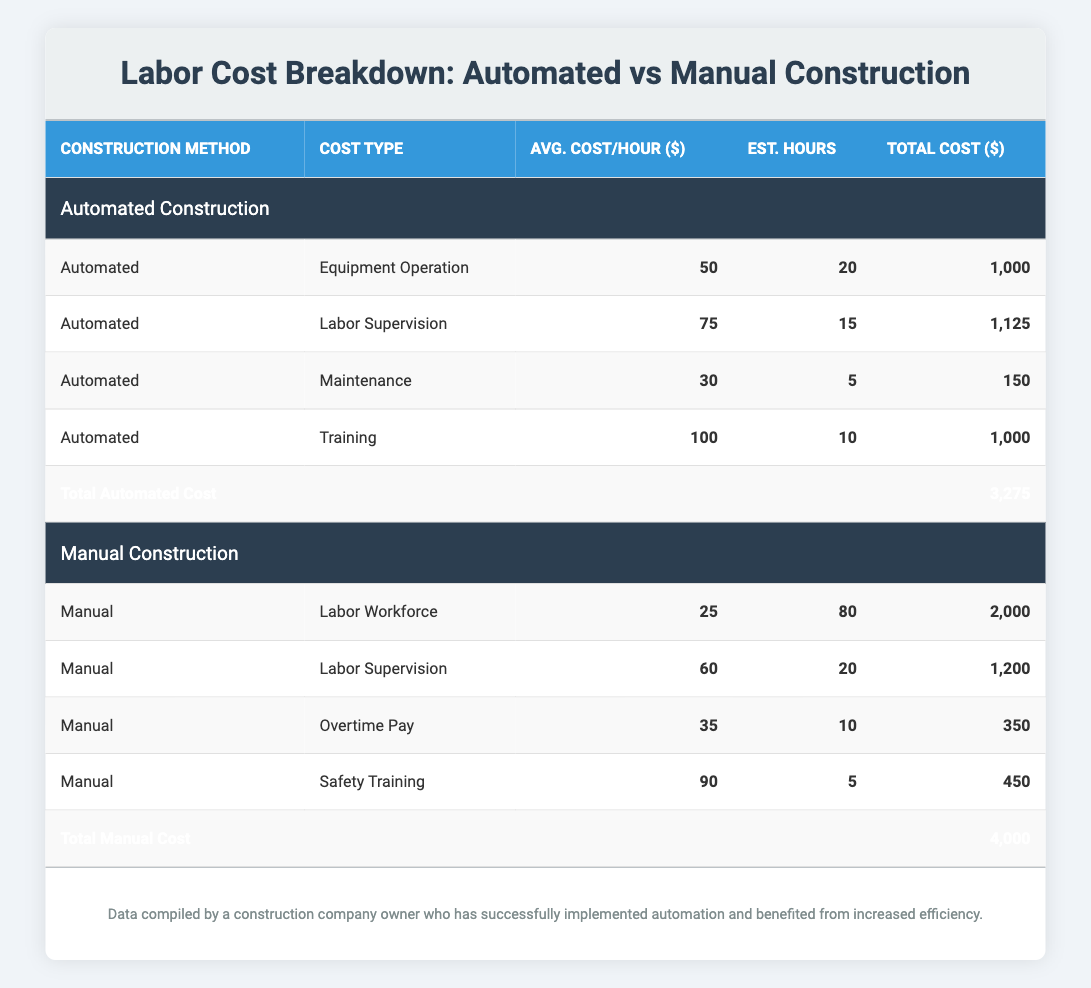What is the total labor cost for automated construction? To find the total for automated construction, we add all the total costs for this method: 1000 + 1125 + 150 + 1000 = 3275.
Answer: 3275 What is the average cost per hour for the labor supervision in manual construction? The average cost per hour for labor supervision in manual construction is explicitly listed in the table as 60.
Answer: 60 Is the total cost of automated construction lower than that of manual construction? The total cost for automated construction is 3275, and for manual construction, it is 4000. Since 3275 is less than 4000, the statement is true.
Answer: Yes What is the difference in total costs between automated and manual construction methods? To find the difference, subtract the total automated cost from the total manual cost: 4000 - 3275 = 725.
Answer: 725 What is the highest average cost per hour across all listed cost types in automated construction? By looking at the average costs per hour in automated construction: 50 (Equipment Operation), 75 (Labor Supervision), 30 (Maintenance), and 100 (Training), the highest is 100 (Training).
Answer: 100 What percentage of the total cost for manual construction is attributed to the labor workforce? The labor workforce cost in manual construction is 2000, and the total manual cost is 4000. To find the percentage: (2000 / 4000) * 100 = 50%.
Answer: 50% Which construction method has a higher total cost for supervision? The total cost for labor supervision in automated construction is 1125 and for manual construction is 1200. Manual construction has higher supervision costs.
Answer: Manual What is the total of the estimated hours for maintenance and safety training together? The estimated hours for maintenance in automated construction is 5 and for safety training in manual construction is also 5. Adding these gives: 5 + 5 = 10.
Answer: 10 What is the overall average cost per hour when both construction methods are considered? For automated construction, the average of costs per hour are 50, 75, 30, and 100, which sums to 255. For manual, the values are 25, 60, 35, and 90, which sums to 210. Combined total hours are 20 + 15 + 5 + 10 (automated) = 50 and 80 + 20 + 10 + 5 (manual) = 115 hours. The overall average is (255 + 210) / (50 + 115) = 465 / 165 = 2.82. Therefore: (Total hours = 165, average costs total = 465).
Answer: 2.82 How much more do training costs in automated construction exceed maintenance costs? Training cost in automated construction totals 1000 and maintenance totals 150. The difference is 1000 - 150 = 850.
Answer: 850 